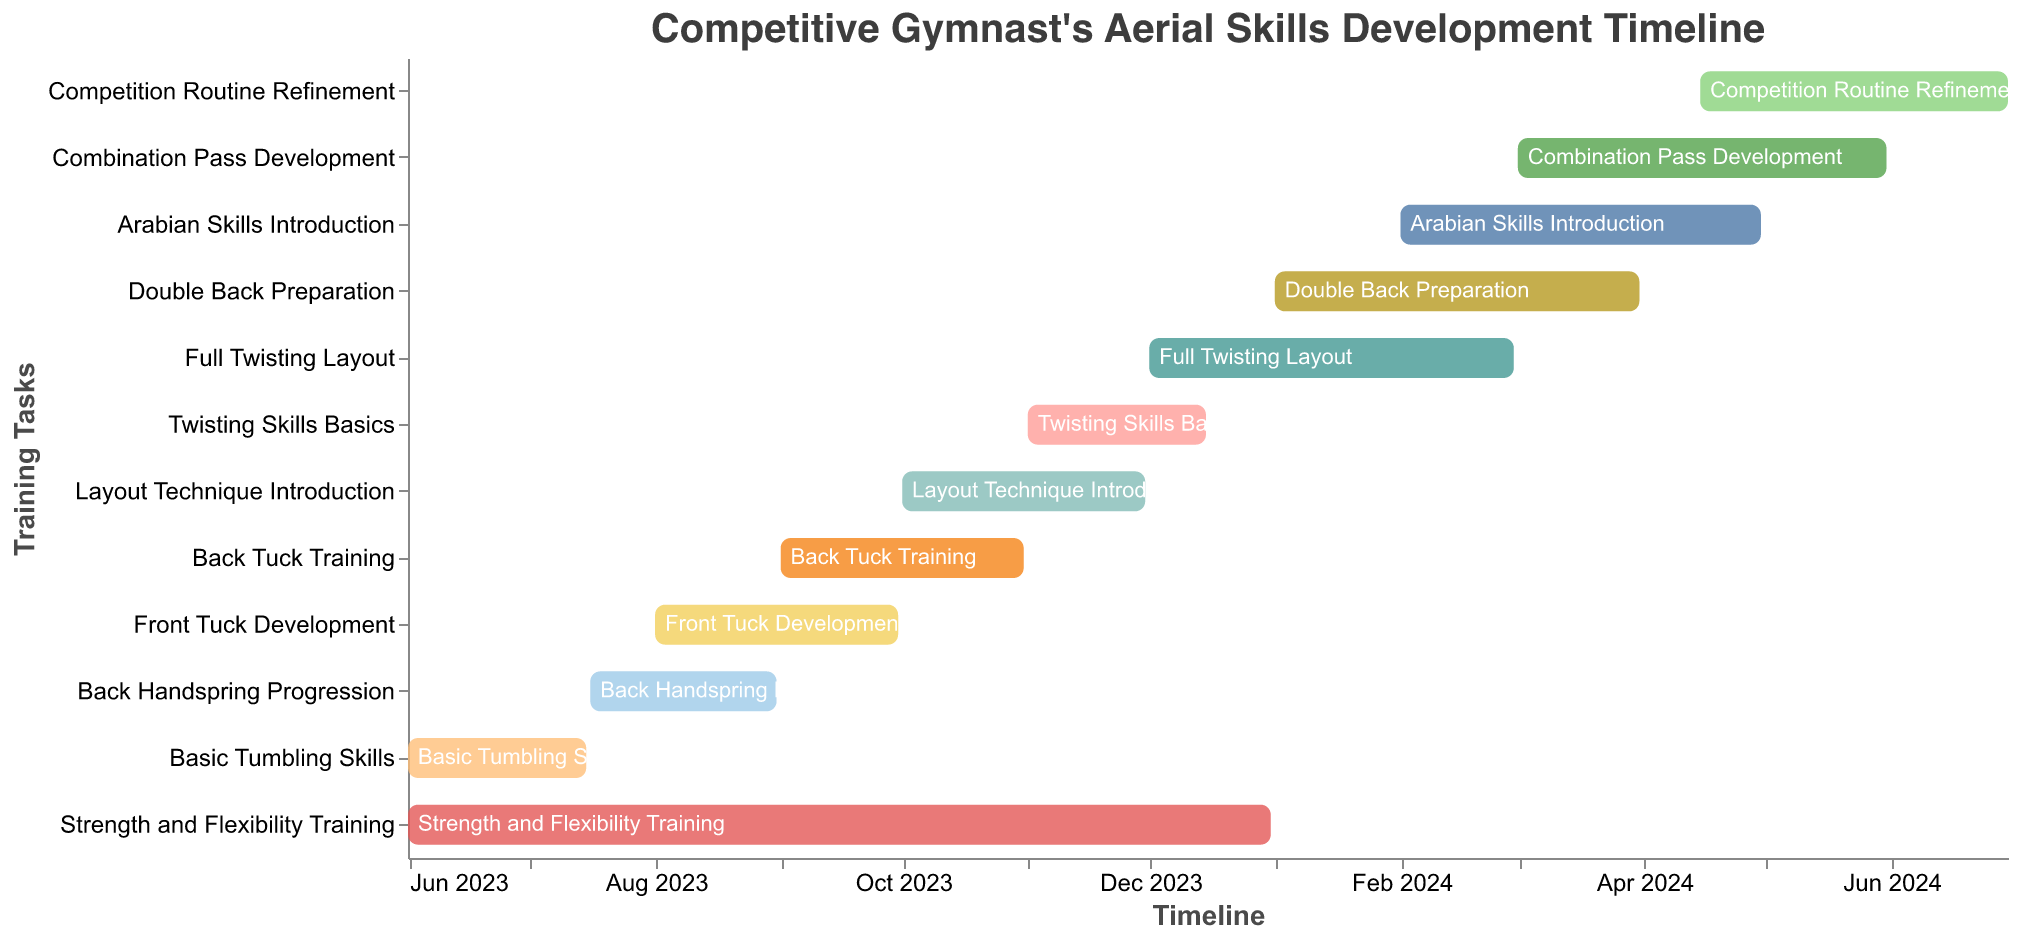What's the title of the figure? The title is located at the top of the Gantt Chart and usually describes the content or purpose of the chart.
Answer: Competitive Gymnast's Aerial Skills Development Timeline What duration is covered by the "Back Handspring Progression"? To find the duration covered, look at the bar for "Back Handspring Progression" and note the Start and End Dates. The bar goes from July 16, 2023, to August 31, 2023.
Answer: July 16, 2023, to August 31, 2023 When does the "Strength and Flexibility Training" start and end? Refer to the bar representing "Strength and Flexibility Training" and check the labels at its start and end. It starts on June 1, 2023, and ends on December 31, 2023.
Answer: June 1, 2023, to December 31, 2023 Which training task has the most extended duration? To determine the task with the most extended duration, compare the lengths of all bars. "Strength and Flexibility Training" spans from June 1, 2023, to December 31, 2023.
Answer: Strength and Flexibility Training Do any training tasks overlap in October 2023? Look at the bars that span the timeline in October 2023. "Back Tuck Training" (September 1, 2023, to October 31, 2023) overlaps with "Layout Technique Introduction" (October 1, 2023, to November 30, 2023).
Answer: Yes, Back Tuck Training and Layout Technique Introduction What is the timeframe for "Competition Routine Refinement"? Check the bar labeled "Competition Routine Refinement" and note the starting and ending dates. It runs from April 15, 2024, to June 30, 2024.
Answer: April 15, 2024, to June 30, 2024 How long does the "Full Twisting Layout" training last? Calculate the duration by noting the start and end dates. The "Full Twisting Layout" starts on December 1, 2023, and ends on February 29, 2024, covering three months.
Answer: Three months Which skill introduction overlaps with the start of "Double Back Preparation"? Identify bars that overlap with the starting date of "Double Back Preparation" (January 1, 2024). "Full Twisting Layout" overlaps since it runs from December 1, 2023, to February 29, 2024.
Answer: Full Twisting Layout How many training tasks start in 2024? Count the bars with start dates in 2024. Tasks starting in 2024 are "Double Back Preparation" (January 1, 2024), "Arabian Skills Introduction" (February 1, 2024), and "Combination Pass Development" (March 1, 2024), making a total of three.
Answer: Three Which training tasks are scheduled to end by December 31, 2023? Check the end dates of the tasks. "Strength and Flexibility Training" ends on December 31, 2023, and "Twisting Skills Basics" ends on December 15, 2023, both finishing in 2023.
Answer: Strength and Flexibility Training, Twisting Skills Basics 